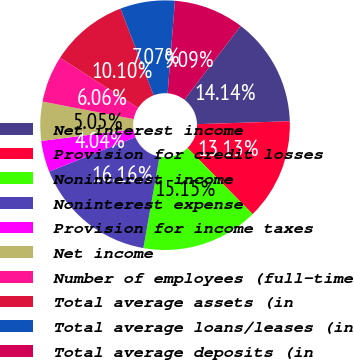Convert chart to OTSL. <chart><loc_0><loc_0><loc_500><loc_500><pie_chart><fcel>Net interest income<fcel>Provision for credit losses<fcel>Noninterest income<fcel>Noninterest expense<fcel>Provision for income taxes<fcel>Net income<fcel>Number of employees (full-time<fcel>Total average assets (in<fcel>Total average loans/leases (in<fcel>Total average deposits (in<nl><fcel>14.14%<fcel>13.13%<fcel>15.15%<fcel>16.16%<fcel>4.04%<fcel>5.05%<fcel>6.06%<fcel>10.1%<fcel>7.07%<fcel>9.09%<nl></chart> 